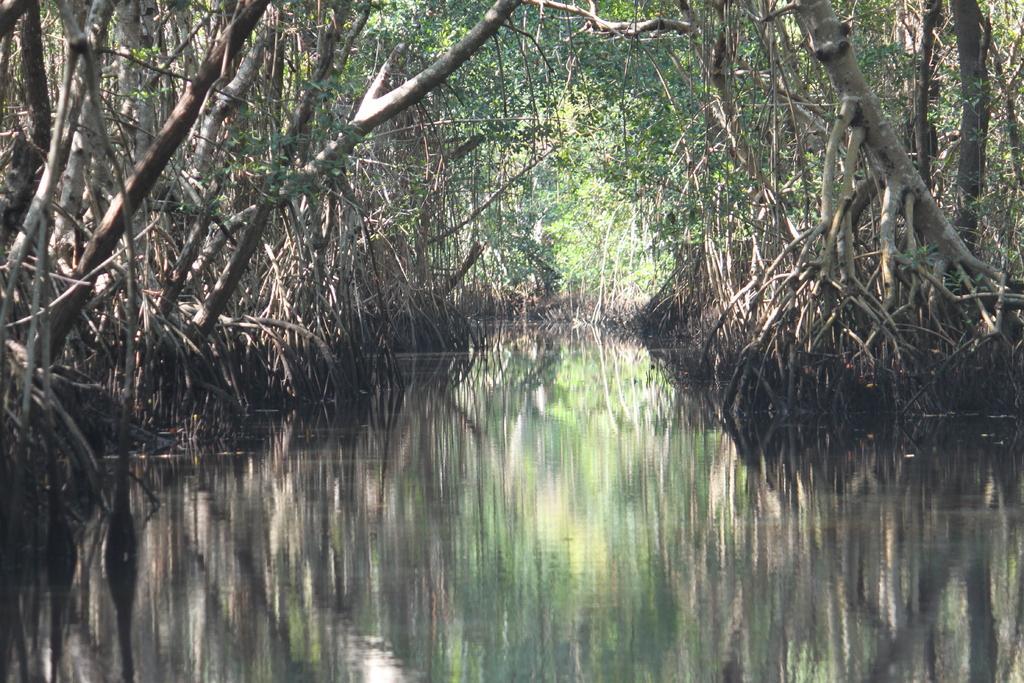In one or two sentences, can you explain what this image depicts? In this image I can see the water. On both sides I can see the dried trees. In the background I can see many green trees. 